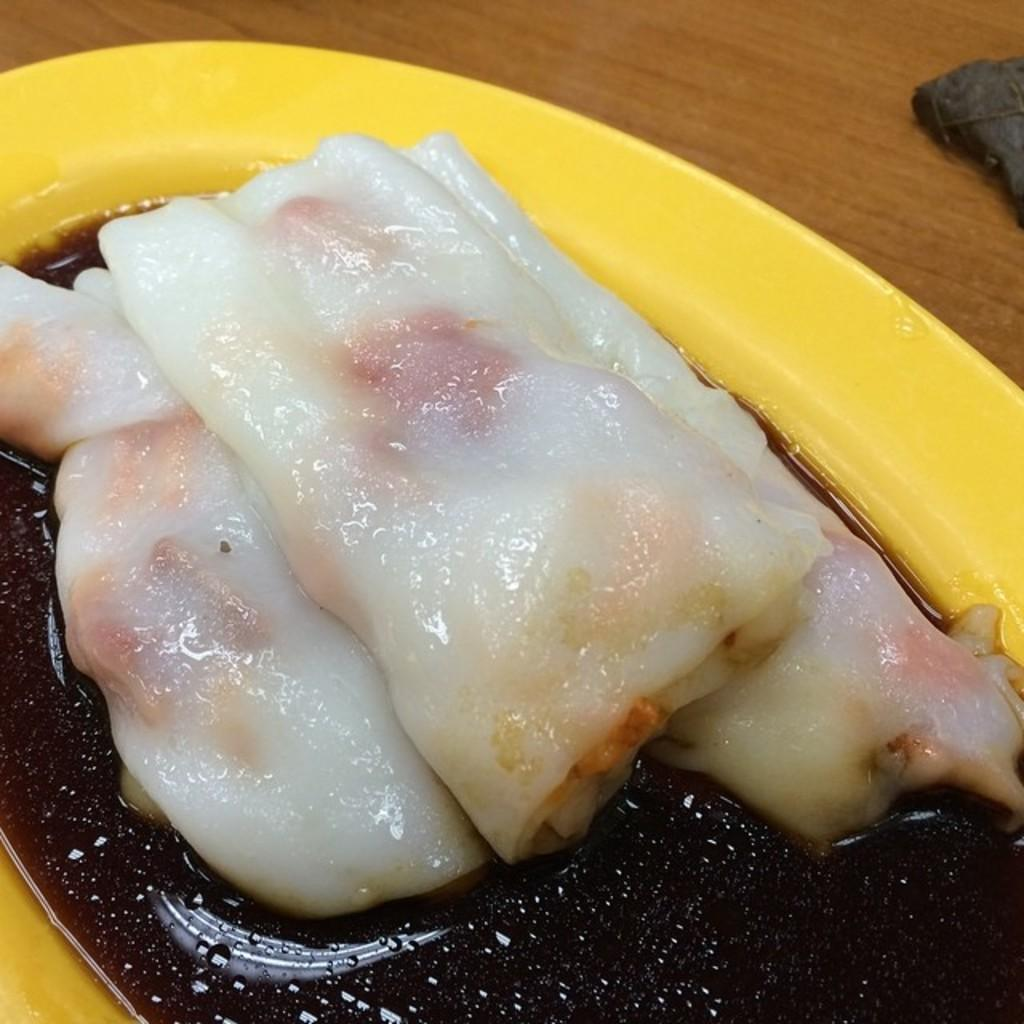What is present on the wooden board in the image? There is a plate in the image, placed on a wooden board. What is the plate holding? There is a food item in the plate. What type of furniture is depicted in the image? There is no furniture present in the image; it only features a plate on a wooden board. How does the plate control the food item in the image? The plate does not control the food item; it simply holds it. 